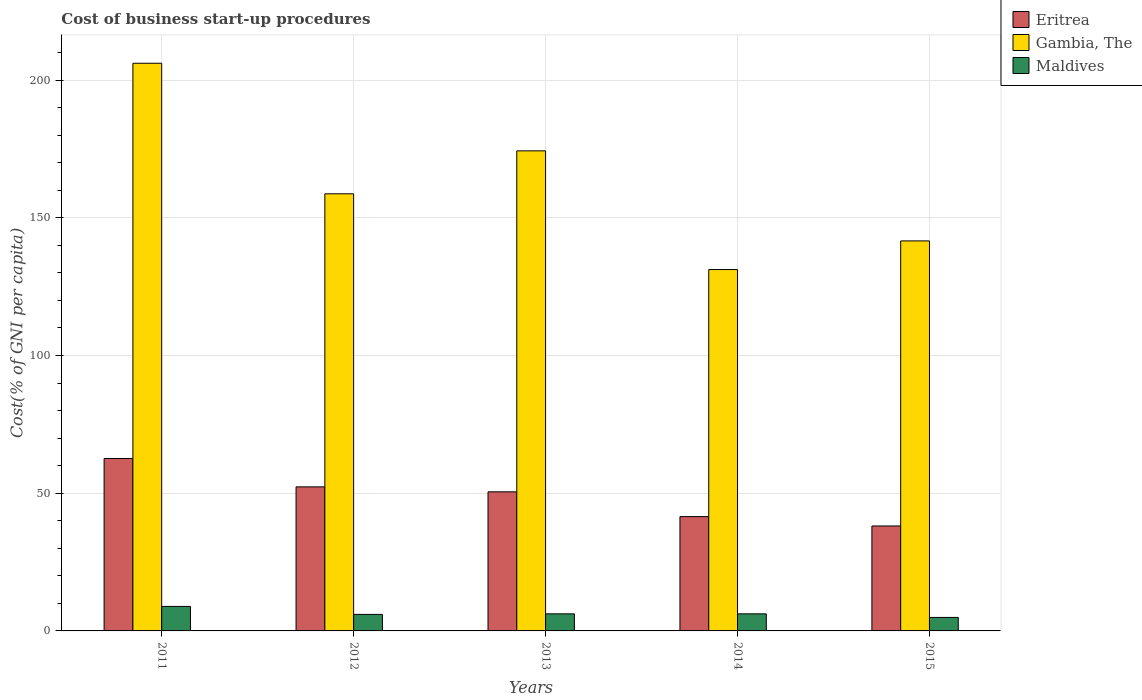How many different coloured bars are there?
Provide a short and direct response. 3. How many bars are there on the 5th tick from the right?
Ensure brevity in your answer.  3. In how many cases, is the number of bars for a given year not equal to the number of legend labels?
Ensure brevity in your answer.  0. What is the cost of business start-up procedures in Eritrea in 2012?
Make the answer very short. 52.3. Across all years, what is the maximum cost of business start-up procedures in Eritrea?
Your response must be concise. 62.6. In which year was the cost of business start-up procedures in Gambia, The maximum?
Your response must be concise. 2011. In which year was the cost of business start-up procedures in Eritrea minimum?
Keep it short and to the point. 2015. What is the total cost of business start-up procedures in Maldives in the graph?
Offer a very short reply. 32.2. What is the difference between the cost of business start-up procedures in Gambia, The in 2014 and that in 2015?
Your answer should be very brief. -10.4. What is the difference between the cost of business start-up procedures in Maldives in 2015 and the cost of business start-up procedures in Gambia, The in 2013?
Offer a terse response. -169.4. What is the average cost of business start-up procedures in Eritrea per year?
Your answer should be compact. 49. In the year 2014, what is the difference between the cost of business start-up procedures in Gambia, The and cost of business start-up procedures in Eritrea?
Give a very brief answer. 89.7. What is the ratio of the cost of business start-up procedures in Gambia, The in 2013 to that in 2015?
Ensure brevity in your answer.  1.23. Is the cost of business start-up procedures in Gambia, The in 2011 less than that in 2012?
Provide a short and direct response. No. What is the difference between the highest and the second highest cost of business start-up procedures in Maldives?
Ensure brevity in your answer.  2.7. What is the difference between the highest and the lowest cost of business start-up procedures in Maldives?
Offer a very short reply. 4. What does the 3rd bar from the left in 2014 represents?
Give a very brief answer. Maldives. What does the 3rd bar from the right in 2012 represents?
Offer a terse response. Eritrea. How many bars are there?
Your answer should be compact. 15. Are all the bars in the graph horizontal?
Provide a succinct answer. No. How many years are there in the graph?
Provide a succinct answer. 5. What is the difference between two consecutive major ticks on the Y-axis?
Your response must be concise. 50. Does the graph contain any zero values?
Ensure brevity in your answer.  No. Does the graph contain grids?
Offer a very short reply. Yes. Where does the legend appear in the graph?
Make the answer very short. Top right. How are the legend labels stacked?
Your response must be concise. Vertical. What is the title of the graph?
Keep it short and to the point. Cost of business start-up procedures. What is the label or title of the Y-axis?
Make the answer very short. Cost(% of GNI per capita). What is the Cost(% of GNI per capita) of Eritrea in 2011?
Your answer should be compact. 62.6. What is the Cost(% of GNI per capita) in Gambia, The in 2011?
Offer a very short reply. 206.1. What is the Cost(% of GNI per capita) of Eritrea in 2012?
Your response must be concise. 52.3. What is the Cost(% of GNI per capita) in Gambia, The in 2012?
Offer a very short reply. 158.7. What is the Cost(% of GNI per capita) in Eritrea in 2013?
Your response must be concise. 50.5. What is the Cost(% of GNI per capita) of Gambia, The in 2013?
Your response must be concise. 174.3. What is the Cost(% of GNI per capita) of Eritrea in 2014?
Make the answer very short. 41.5. What is the Cost(% of GNI per capita) in Gambia, The in 2014?
Your answer should be very brief. 131.2. What is the Cost(% of GNI per capita) in Eritrea in 2015?
Your answer should be compact. 38.1. What is the Cost(% of GNI per capita) in Gambia, The in 2015?
Offer a very short reply. 141.6. Across all years, what is the maximum Cost(% of GNI per capita) in Eritrea?
Provide a short and direct response. 62.6. Across all years, what is the maximum Cost(% of GNI per capita) of Gambia, The?
Provide a short and direct response. 206.1. Across all years, what is the maximum Cost(% of GNI per capita) in Maldives?
Give a very brief answer. 8.9. Across all years, what is the minimum Cost(% of GNI per capita) of Eritrea?
Your response must be concise. 38.1. Across all years, what is the minimum Cost(% of GNI per capita) in Gambia, The?
Keep it short and to the point. 131.2. What is the total Cost(% of GNI per capita) of Eritrea in the graph?
Provide a short and direct response. 245. What is the total Cost(% of GNI per capita) of Gambia, The in the graph?
Your answer should be compact. 811.9. What is the total Cost(% of GNI per capita) in Maldives in the graph?
Ensure brevity in your answer.  32.2. What is the difference between the Cost(% of GNI per capita) in Eritrea in 2011 and that in 2012?
Your answer should be compact. 10.3. What is the difference between the Cost(% of GNI per capita) of Gambia, The in 2011 and that in 2012?
Keep it short and to the point. 47.4. What is the difference between the Cost(% of GNI per capita) in Gambia, The in 2011 and that in 2013?
Offer a terse response. 31.8. What is the difference between the Cost(% of GNI per capita) of Eritrea in 2011 and that in 2014?
Give a very brief answer. 21.1. What is the difference between the Cost(% of GNI per capita) of Gambia, The in 2011 and that in 2014?
Offer a very short reply. 74.9. What is the difference between the Cost(% of GNI per capita) of Maldives in 2011 and that in 2014?
Provide a short and direct response. 2.7. What is the difference between the Cost(% of GNI per capita) of Eritrea in 2011 and that in 2015?
Your answer should be compact. 24.5. What is the difference between the Cost(% of GNI per capita) of Gambia, The in 2011 and that in 2015?
Your answer should be compact. 64.5. What is the difference between the Cost(% of GNI per capita) of Gambia, The in 2012 and that in 2013?
Offer a terse response. -15.6. What is the difference between the Cost(% of GNI per capita) in Maldives in 2012 and that in 2013?
Give a very brief answer. -0.2. What is the difference between the Cost(% of GNI per capita) in Gambia, The in 2012 and that in 2014?
Ensure brevity in your answer.  27.5. What is the difference between the Cost(% of GNI per capita) of Eritrea in 2012 and that in 2015?
Give a very brief answer. 14.2. What is the difference between the Cost(% of GNI per capita) in Maldives in 2012 and that in 2015?
Your response must be concise. 1.1. What is the difference between the Cost(% of GNI per capita) in Eritrea in 2013 and that in 2014?
Your response must be concise. 9. What is the difference between the Cost(% of GNI per capita) in Gambia, The in 2013 and that in 2014?
Your answer should be very brief. 43.1. What is the difference between the Cost(% of GNI per capita) in Gambia, The in 2013 and that in 2015?
Offer a terse response. 32.7. What is the difference between the Cost(% of GNI per capita) of Maldives in 2013 and that in 2015?
Your response must be concise. 1.3. What is the difference between the Cost(% of GNI per capita) in Eritrea in 2014 and that in 2015?
Make the answer very short. 3.4. What is the difference between the Cost(% of GNI per capita) in Eritrea in 2011 and the Cost(% of GNI per capita) in Gambia, The in 2012?
Provide a succinct answer. -96.1. What is the difference between the Cost(% of GNI per capita) in Eritrea in 2011 and the Cost(% of GNI per capita) in Maldives in 2012?
Make the answer very short. 56.6. What is the difference between the Cost(% of GNI per capita) of Gambia, The in 2011 and the Cost(% of GNI per capita) of Maldives in 2012?
Your response must be concise. 200.1. What is the difference between the Cost(% of GNI per capita) of Eritrea in 2011 and the Cost(% of GNI per capita) of Gambia, The in 2013?
Your response must be concise. -111.7. What is the difference between the Cost(% of GNI per capita) in Eritrea in 2011 and the Cost(% of GNI per capita) in Maldives in 2013?
Keep it short and to the point. 56.4. What is the difference between the Cost(% of GNI per capita) in Gambia, The in 2011 and the Cost(% of GNI per capita) in Maldives in 2013?
Your answer should be very brief. 199.9. What is the difference between the Cost(% of GNI per capita) in Eritrea in 2011 and the Cost(% of GNI per capita) in Gambia, The in 2014?
Provide a succinct answer. -68.6. What is the difference between the Cost(% of GNI per capita) in Eritrea in 2011 and the Cost(% of GNI per capita) in Maldives in 2014?
Your response must be concise. 56.4. What is the difference between the Cost(% of GNI per capita) in Gambia, The in 2011 and the Cost(% of GNI per capita) in Maldives in 2014?
Keep it short and to the point. 199.9. What is the difference between the Cost(% of GNI per capita) of Eritrea in 2011 and the Cost(% of GNI per capita) of Gambia, The in 2015?
Your answer should be compact. -79. What is the difference between the Cost(% of GNI per capita) of Eritrea in 2011 and the Cost(% of GNI per capita) of Maldives in 2015?
Make the answer very short. 57.7. What is the difference between the Cost(% of GNI per capita) in Gambia, The in 2011 and the Cost(% of GNI per capita) in Maldives in 2015?
Ensure brevity in your answer.  201.2. What is the difference between the Cost(% of GNI per capita) of Eritrea in 2012 and the Cost(% of GNI per capita) of Gambia, The in 2013?
Your response must be concise. -122. What is the difference between the Cost(% of GNI per capita) of Eritrea in 2012 and the Cost(% of GNI per capita) of Maldives in 2013?
Ensure brevity in your answer.  46.1. What is the difference between the Cost(% of GNI per capita) of Gambia, The in 2012 and the Cost(% of GNI per capita) of Maldives in 2013?
Your response must be concise. 152.5. What is the difference between the Cost(% of GNI per capita) in Eritrea in 2012 and the Cost(% of GNI per capita) in Gambia, The in 2014?
Your response must be concise. -78.9. What is the difference between the Cost(% of GNI per capita) in Eritrea in 2012 and the Cost(% of GNI per capita) in Maldives in 2014?
Offer a terse response. 46.1. What is the difference between the Cost(% of GNI per capita) in Gambia, The in 2012 and the Cost(% of GNI per capita) in Maldives in 2014?
Ensure brevity in your answer.  152.5. What is the difference between the Cost(% of GNI per capita) in Eritrea in 2012 and the Cost(% of GNI per capita) in Gambia, The in 2015?
Keep it short and to the point. -89.3. What is the difference between the Cost(% of GNI per capita) in Eritrea in 2012 and the Cost(% of GNI per capita) in Maldives in 2015?
Provide a succinct answer. 47.4. What is the difference between the Cost(% of GNI per capita) of Gambia, The in 2012 and the Cost(% of GNI per capita) of Maldives in 2015?
Your response must be concise. 153.8. What is the difference between the Cost(% of GNI per capita) in Eritrea in 2013 and the Cost(% of GNI per capita) in Gambia, The in 2014?
Provide a short and direct response. -80.7. What is the difference between the Cost(% of GNI per capita) in Eritrea in 2013 and the Cost(% of GNI per capita) in Maldives in 2014?
Make the answer very short. 44.3. What is the difference between the Cost(% of GNI per capita) in Gambia, The in 2013 and the Cost(% of GNI per capita) in Maldives in 2014?
Make the answer very short. 168.1. What is the difference between the Cost(% of GNI per capita) in Eritrea in 2013 and the Cost(% of GNI per capita) in Gambia, The in 2015?
Provide a succinct answer. -91.1. What is the difference between the Cost(% of GNI per capita) of Eritrea in 2013 and the Cost(% of GNI per capita) of Maldives in 2015?
Ensure brevity in your answer.  45.6. What is the difference between the Cost(% of GNI per capita) of Gambia, The in 2013 and the Cost(% of GNI per capita) of Maldives in 2015?
Give a very brief answer. 169.4. What is the difference between the Cost(% of GNI per capita) in Eritrea in 2014 and the Cost(% of GNI per capita) in Gambia, The in 2015?
Keep it short and to the point. -100.1. What is the difference between the Cost(% of GNI per capita) in Eritrea in 2014 and the Cost(% of GNI per capita) in Maldives in 2015?
Ensure brevity in your answer.  36.6. What is the difference between the Cost(% of GNI per capita) of Gambia, The in 2014 and the Cost(% of GNI per capita) of Maldives in 2015?
Ensure brevity in your answer.  126.3. What is the average Cost(% of GNI per capita) of Eritrea per year?
Offer a very short reply. 49. What is the average Cost(% of GNI per capita) in Gambia, The per year?
Make the answer very short. 162.38. What is the average Cost(% of GNI per capita) of Maldives per year?
Keep it short and to the point. 6.44. In the year 2011, what is the difference between the Cost(% of GNI per capita) of Eritrea and Cost(% of GNI per capita) of Gambia, The?
Offer a terse response. -143.5. In the year 2011, what is the difference between the Cost(% of GNI per capita) of Eritrea and Cost(% of GNI per capita) of Maldives?
Your response must be concise. 53.7. In the year 2011, what is the difference between the Cost(% of GNI per capita) of Gambia, The and Cost(% of GNI per capita) of Maldives?
Your answer should be very brief. 197.2. In the year 2012, what is the difference between the Cost(% of GNI per capita) in Eritrea and Cost(% of GNI per capita) in Gambia, The?
Your answer should be very brief. -106.4. In the year 2012, what is the difference between the Cost(% of GNI per capita) in Eritrea and Cost(% of GNI per capita) in Maldives?
Ensure brevity in your answer.  46.3. In the year 2012, what is the difference between the Cost(% of GNI per capita) in Gambia, The and Cost(% of GNI per capita) in Maldives?
Offer a terse response. 152.7. In the year 2013, what is the difference between the Cost(% of GNI per capita) of Eritrea and Cost(% of GNI per capita) of Gambia, The?
Your response must be concise. -123.8. In the year 2013, what is the difference between the Cost(% of GNI per capita) of Eritrea and Cost(% of GNI per capita) of Maldives?
Your answer should be very brief. 44.3. In the year 2013, what is the difference between the Cost(% of GNI per capita) of Gambia, The and Cost(% of GNI per capita) of Maldives?
Offer a terse response. 168.1. In the year 2014, what is the difference between the Cost(% of GNI per capita) in Eritrea and Cost(% of GNI per capita) in Gambia, The?
Your response must be concise. -89.7. In the year 2014, what is the difference between the Cost(% of GNI per capita) in Eritrea and Cost(% of GNI per capita) in Maldives?
Keep it short and to the point. 35.3. In the year 2014, what is the difference between the Cost(% of GNI per capita) of Gambia, The and Cost(% of GNI per capita) of Maldives?
Make the answer very short. 125. In the year 2015, what is the difference between the Cost(% of GNI per capita) in Eritrea and Cost(% of GNI per capita) in Gambia, The?
Give a very brief answer. -103.5. In the year 2015, what is the difference between the Cost(% of GNI per capita) in Eritrea and Cost(% of GNI per capita) in Maldives?
Ensure brevity in your answer.  33.2. In the year 2015, what is the difference between the Cost(% of GNI per capita) in Gambia, The and Cost(% of GNI per capita) in Maldives?
Your response must be concise. 136.7. What is the ratio of the Cost(% of GNI per capita) of Eritrea in 2011 to that in 2012?
Your response must be concise. 1.2. What is the ratio of the Cost(% of GNI per capita) of Gambia, The in 2011 to that in 2012?
Your answer should be compact. 1.3. What is the ratio of the Cost(% of GNI per capita) of Maldives in 2011 to that in 2012?
Provide a short and direct response. 1.48. What is the ratio of the Cost(% of GNI per capita) of Eritrea in 2011 to that in 2013?
Your answer should be very brief. 1.24. What is the ratio of the Cost(% of GNI per capita) of Gambia, The in 2011 to that in 2013?
Ensure brevity in your answer.  1.18. What is the ratio of the Cost(% of GNI per capita) of Maldives in 2011 to that in 2013?
Your answer should be compact. 1.44. What is the ratio of the Cost(% of GNI per capita) in Eritrea in 2011 to that in 2014?
Keep it short and to the point. 1.51. What is the ratio of the Cost(% of GNI per capita) of Gambia, The in 2011 to that in 2014?
Provide a short and direct response. 1.57. What is the ratio of the Cost(% of GNI per capita) in Maldives in 2011 to that in 2014?
Your response must be concise. 1.44. What is the ratio of the Cost(% of GNI per capita) of Eritrea in 2011 to that in 2015?
Provide a short and direct response. 1.64. What is the ratio of the Cost(% of GNI per capita) of Gambia, The in 2011 to that in 2015?
Your answer should be compact. 1.46. What is the ratio of the Cost(% of GNI per capita) in Maldives in 2011 to that in 2015?
Ensure brevity in your answer.  1.82. What is the ratio of the Cost(% of GNI per capita) of Eritrea in 2012 to that in 2013?
Offer a terse response. 1.04. What is the ratio of the Cost(% of GNI per capita) of Gambia, The in 2012 to that in 2013?
Make the answer very short. 0.91. What is the ratio of the Cost(% of GNI per capita) of Eritrea in 2012 to that in 2014?
Offer a terse response. 1.26. What is the ratio of the Cost(% of GNI per capita) in Gambia, The in 2012 to that in 2014?
Provide a succinct answer. 1.21. What is the ratio of the Cost(% of GNI per capita) in Maldives in 2012 to that in 2014?
Provide a succinct answer. 0.97. What is the ratio of the Cost(% of GNI per capita) of Eritrea in 2012 to that in 2015?
Make the answer very short. 1.37. What is the ratio of the Cost(% of GNI per capita) in Gambia, The in 2012 to that in 2015?
Provide a succinct answer. 1.12. What is the ratio of the Cost(% of GNI per capita) of Maldives in 2012 to that in 2015?
Make the answer very short. 1.22. What is the ratio of the Cost(% of GNI per capita) in Eritrea in 2013 to that in 2014?
Provide a short and direct response. 1.22. What is the ratio of the Cost(% of GNI per capita) in Gambia, The in 2013 to that in 2014?
Give a very brief answer. 1.33. What is the ratio of the Cost(% of GNI per capita) of Eritrea in 2013 to that in 2015?
Make the answer very short. 1.33. What is the ratio of the Cost(% of GNI per capita) in Gambia, The in 2013 to that in 2015?
Offer a very short reply. 1.23. What is the ratio of the Cost(% of GNI per capita) in Maldives in 2013 to that in 2015?
Offer a terse response. 1.27. What is the ratio of the Cost(% of GNI per capita) in Eritrea in 2014 to that in 2015?
Your answer should be compact. 1.09. What is the ratio of the Cost(% of GNI per capita) of Gambia, The in 2014 to that in 2015?
Your response must be concise. 0.93. What is the ratio of the Cost(% of GNI per capita) of Maldives in 2014 to that in 2015?
Your answer should be very brief. 1.27. What is the difference between the highest and the second highest Cost(% of GNI per capita) in Gambia, The?
Your answer should be very brief. 31.8. What is the difference between the highest and the lowest Cost(% of GNI per capita) in Gambia, The?
Offer a terse response. 74.9. 